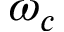<formula> <loc_0><loc_0><loc_500><loc_500>\omega _ { c }</formula> 